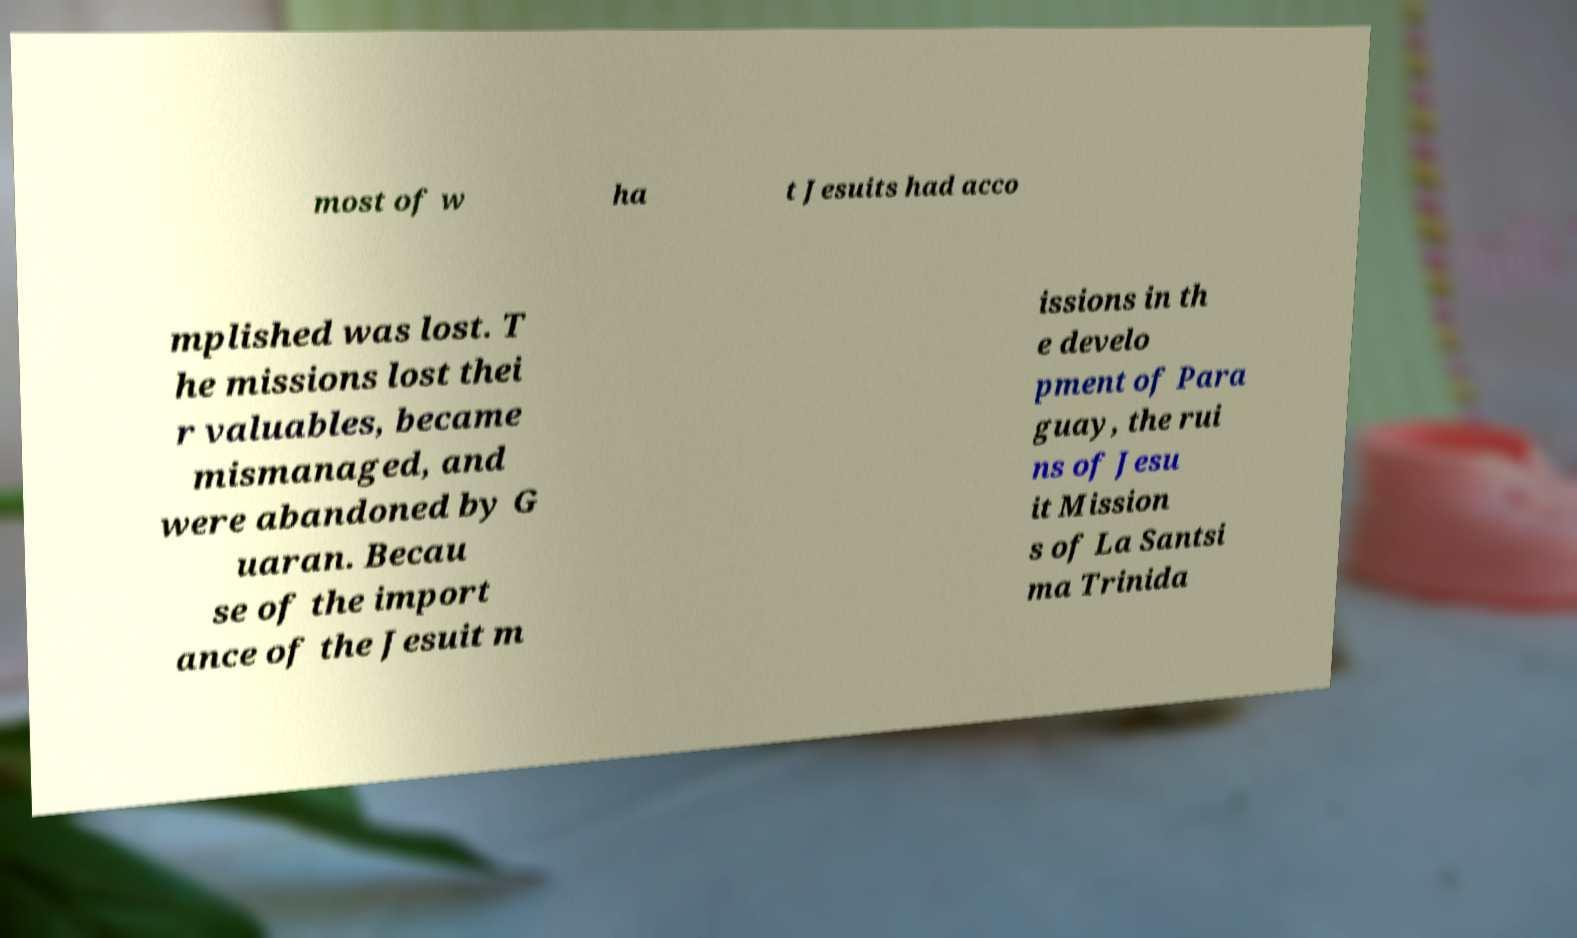Can you read and provide the text displayed in the image?This photo seems to have some interesting text. Can you extract and type it out for me? most of w ha t Jesuits had acco mplished was lost. T he missions lost thei r valuables, became mismanaged, and were abandoned by G uaran. Becau se of the import ance of the Jesuit m issions in th e develo pment of Para guay, the rui ns of Jesu it Mission s of La Santsi ma Trinida 